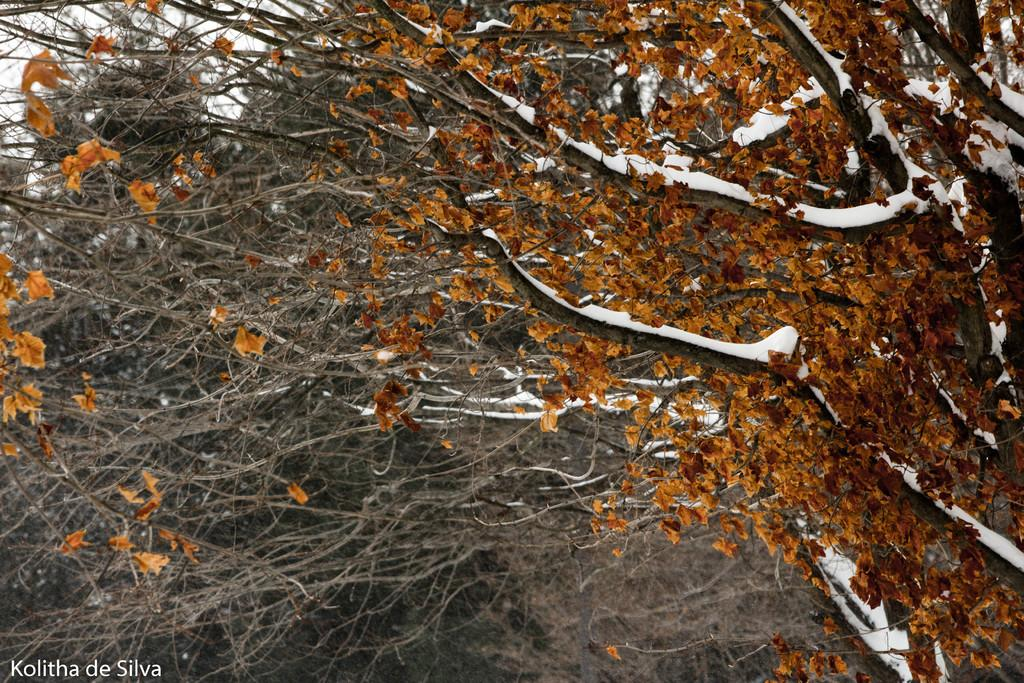What type of vegetation is present in the image? There is a group of trees in the image. What is the condition of the trees in the image? Some trees in the image are covered with snow. What is visible at the top of the image? The sky is visible at the top of the image. How many feet are visible in the image? There are no feet present in the image. What direction are the trees facing in the image? The direction the trees are facing cannot be determined from the image. 